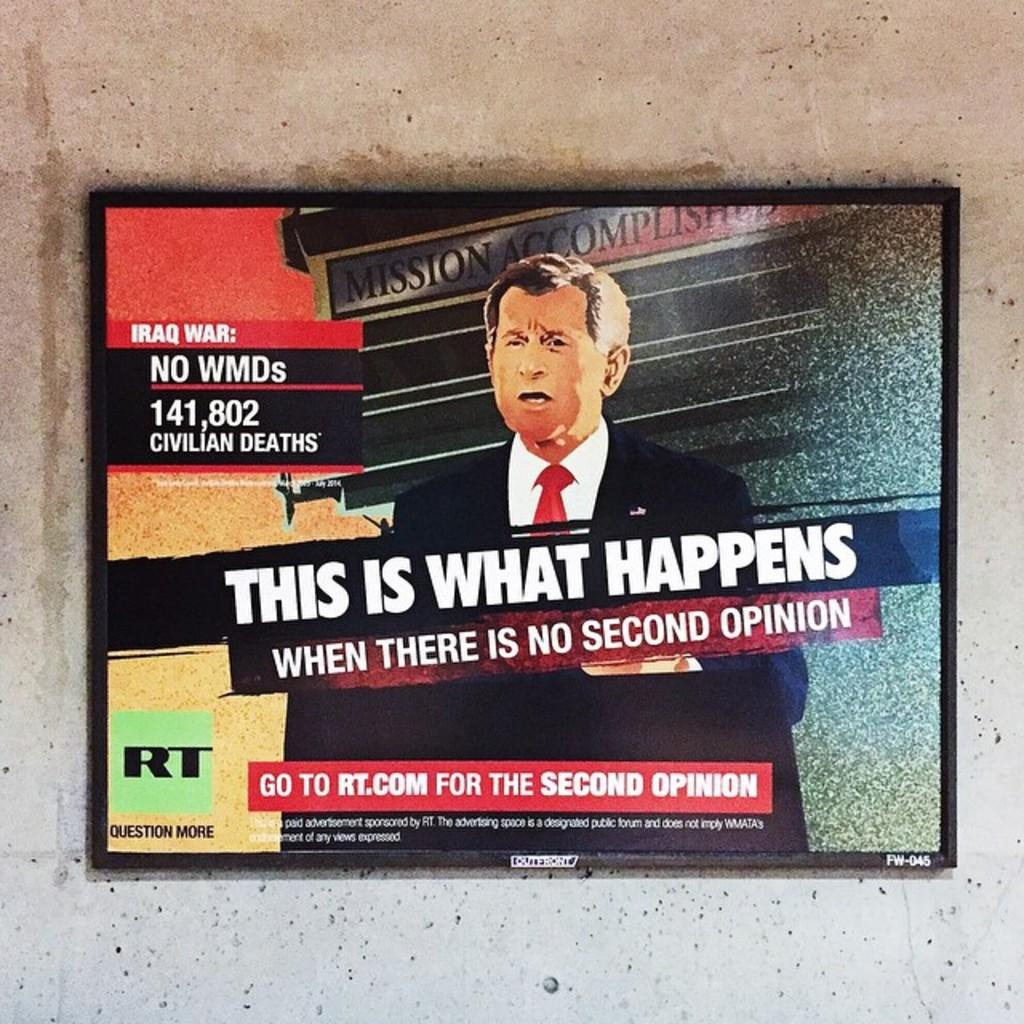What is mounted on the wall in the image? There is a TV on the wall in the image. What is shown on the TV screen? The TV screen displays a picture of a person and some texts. Can you describe the content of the texts on the TV screen? Unfortunately, the specific content of the texts cannot be determined from the image. How many horses are visible in the image? There are no horses present in the image. What type of apples are being used as decorations in the image? There are no apples present in the image. 